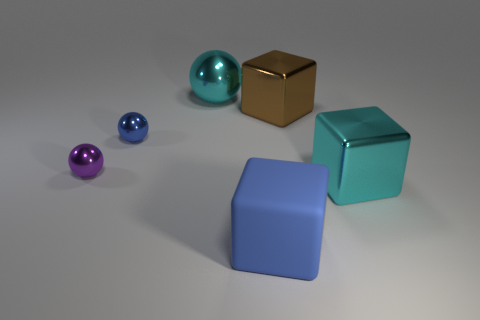Add 2 shiny things. How many objects exist? 8 Subtract 0 gray blocks. How many objects are left? 6 Subtract all blue rubber things. Subtract all small blue matte spheres. How many objects are left? 5 Add 2 tiny balls. How many tiny balls are left? 4 Add 1 tiny purple rubber blocks. How many tiny purple rubber blocks exist? 1 